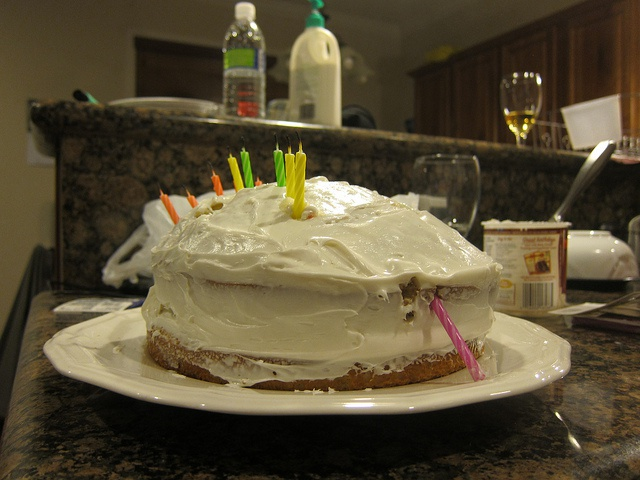Describe the objects in this image and their specific colors. I can see cake in black, tan, and olive tones, bottle in black, olive, and tan tones, bottle in black, darkgreen, gray, and maroon tones, cup in black, darkgreen, and gray tones, and bowl in black, gray, and tan tones in this image. 